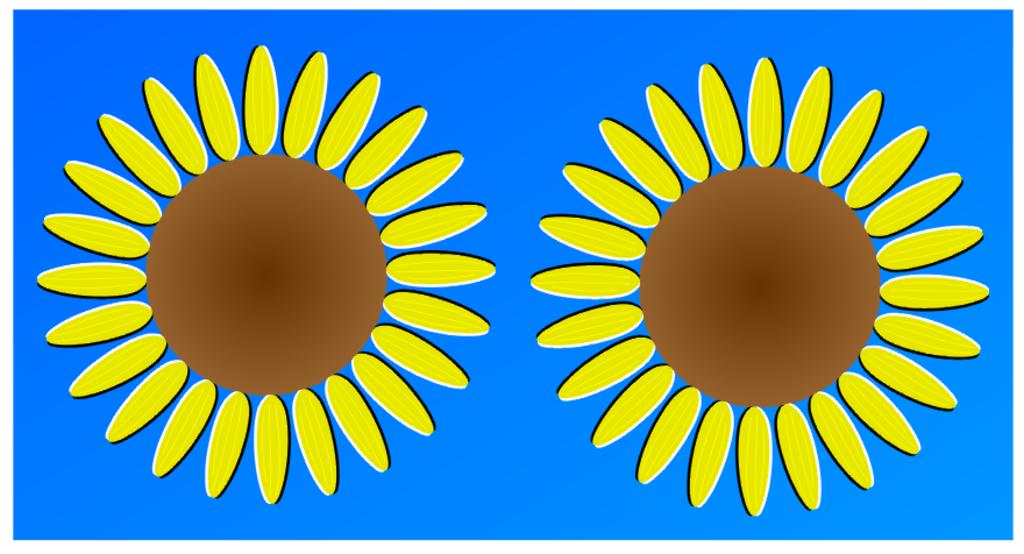What type of living organisms can beings can be seen in the image? There are flowers in the image. What color is the background of the image? The background of the image is blue. What type of shoes are the flowers wearing in the image? There are no shoes present in the image, as flowers do not wear shoes. 